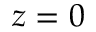Convert formula to latex. <formula><loc_0><loc_0><loc_500><loc_500>z = 0</formula> 